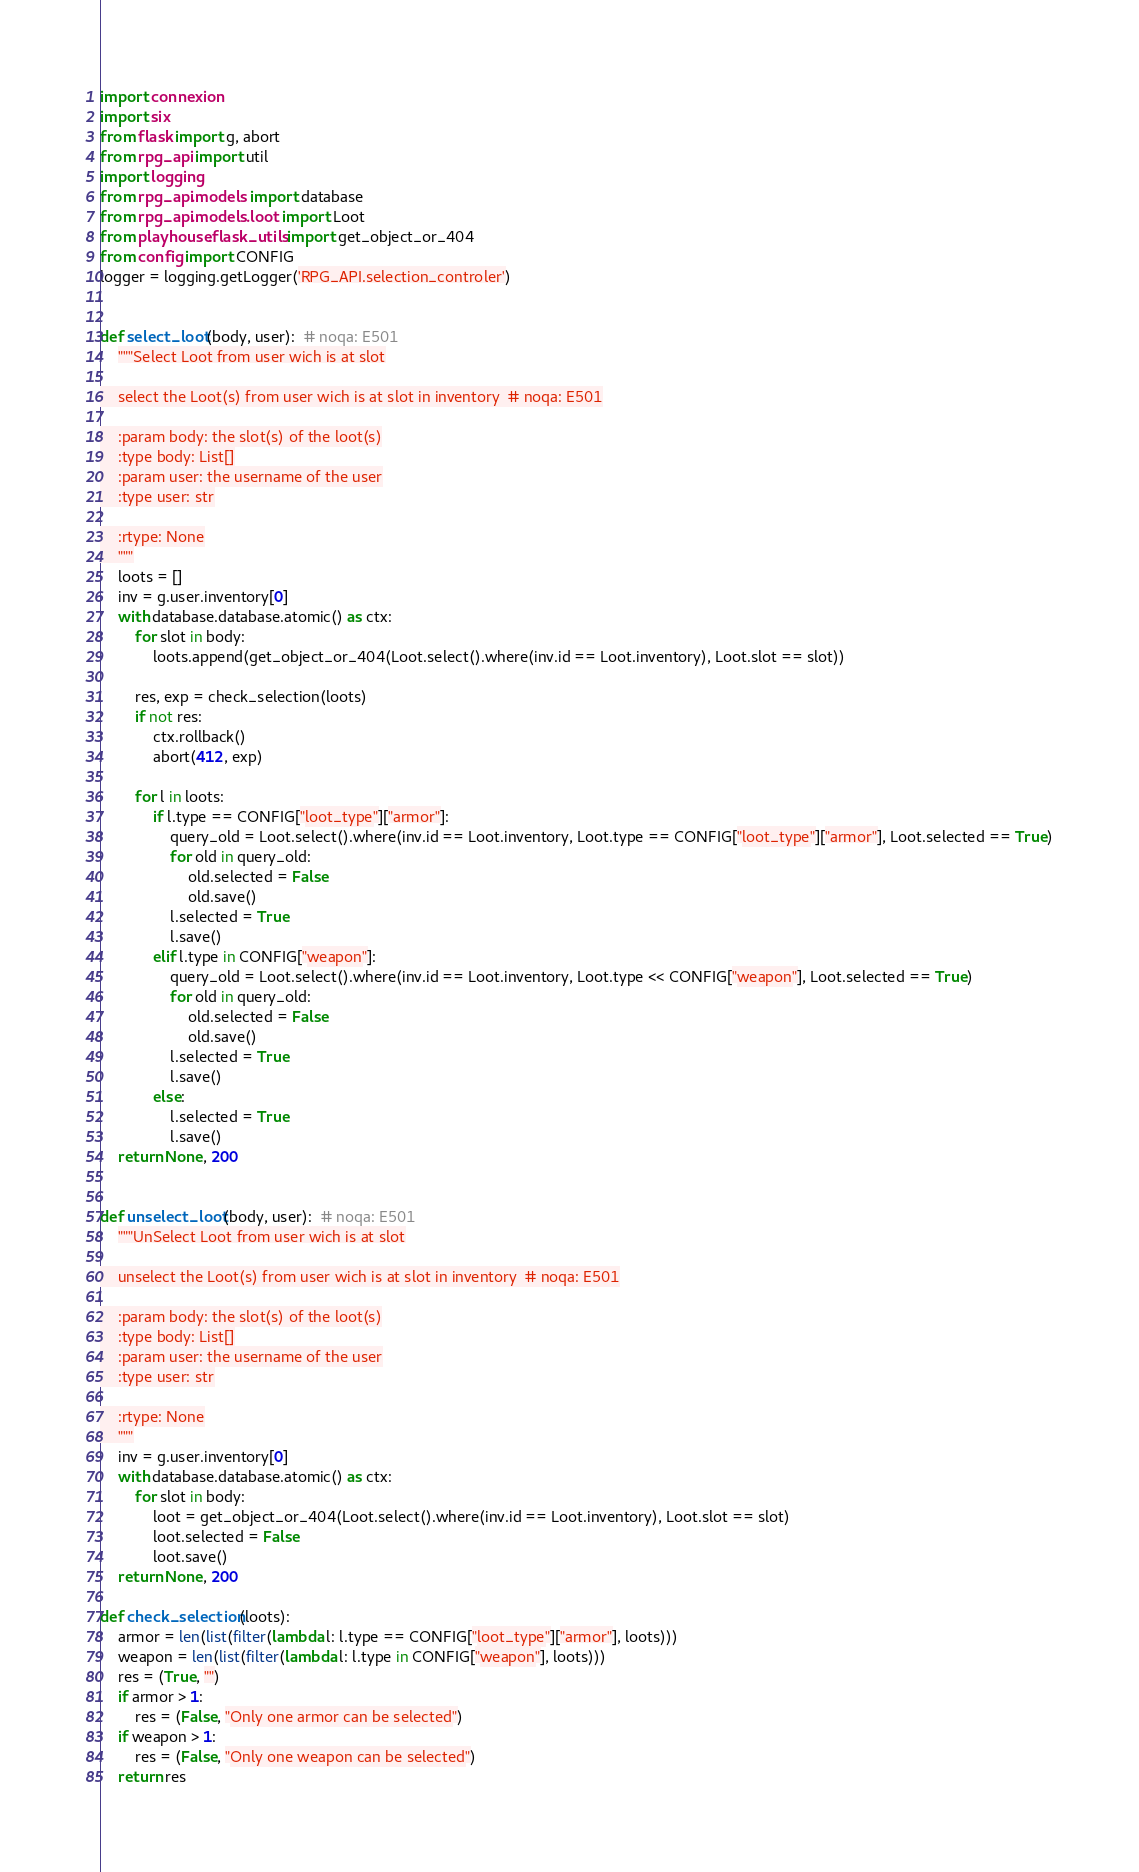<code> <loc_0><loc_0><loc_500><loc_500><_Python_>import connexion
import six
from flask import g, abort
from rpg_api import util
import logging
from rpg_api.models import database
from rpg_api.models.loot import Loot
from playhouse.flask_utils import get_object_or_404
from config import CONFIG
logger = logging.getLogger('RPG_API.selection_controler')


def select_loot(body, user):  # noqa: E501
    """Select Loot from user wich is at slot

    select the Loot(s) from user wich is at slot in inventory  # noqa: E501

    :param body: the slot(s) of the loot(s)
    :type body: List[]
    :param user: the username of the user
    :type user: str

    :rtype: None
    """
    loots = []
    inv = g.user.inventory[0]
    with database.database.atomic() as ctx:
        for slot in body:
            loots.append(get_object_or_404(Loot.select().where(inv.id == Loot.inventory), Loot.slot == slot))

        res, exp = check_selection(loots)
        if not res:
            ctx.rollback()
            abort(412, exp)
        
        for l in loots:
            if l.type == CONFIG["loot_type"]["armor"]:
                query_old = Loot.select().where(inv.id == Loot.inventory, Loot.type == CONFIG["loot_type"]["armor"], Loot.selected == True)
                for old in query_old:
                    old.selected = False
                    old.save()
                l.selected = True
                l.save()
            elif l.type in CONFIG["weapon"]:
                query_old = Loot.select().where(inv.id == Loot.inventory, Loot.type << CONFIG["weapon"], Loot.selected == True)
                for old in query_old:
                    old.selected = False
                    old.save()
                l.selected = True
                l.save()
            else:
                l.selected = True
                l.save()
    return None, 200


def unselect_loot(body, user):  # noqa: E501
    """UnSelect Loot from user wich is at slot

    unselect the Loot(s) from user wich is at slot in inventory  # noqa: E501

    :param body: the slot(s) of the loot(s)
    :type body: List[]
    :param user: the username of the user
    :type user: str

    :rtype: None
    """
    inv = g.user.inventory[0]
    with database.database.atomic() as ctx:
        for slot in body:
            loot = get_object_or_404(Loot.select().where(inv.id == Loot.inventory), Loot.slot == slot)
            loot.selected = False
            loot.save()
    return None, 200

def check_selection(loots):
    armor = len(list(filter(lambda l: l.type == CONFIG["loot_type"]["armor"], loots)))
    weapon = len(list(filter(lambda l: l.type in CONFIG["weapon"], loots)))
    res = (True, "")
    if armor > 1:
        res = (False, "Only one armor can be selected")
    if weapon > 1:
        res = (False, "Only one weapon can be selected")
    return res
</code> 